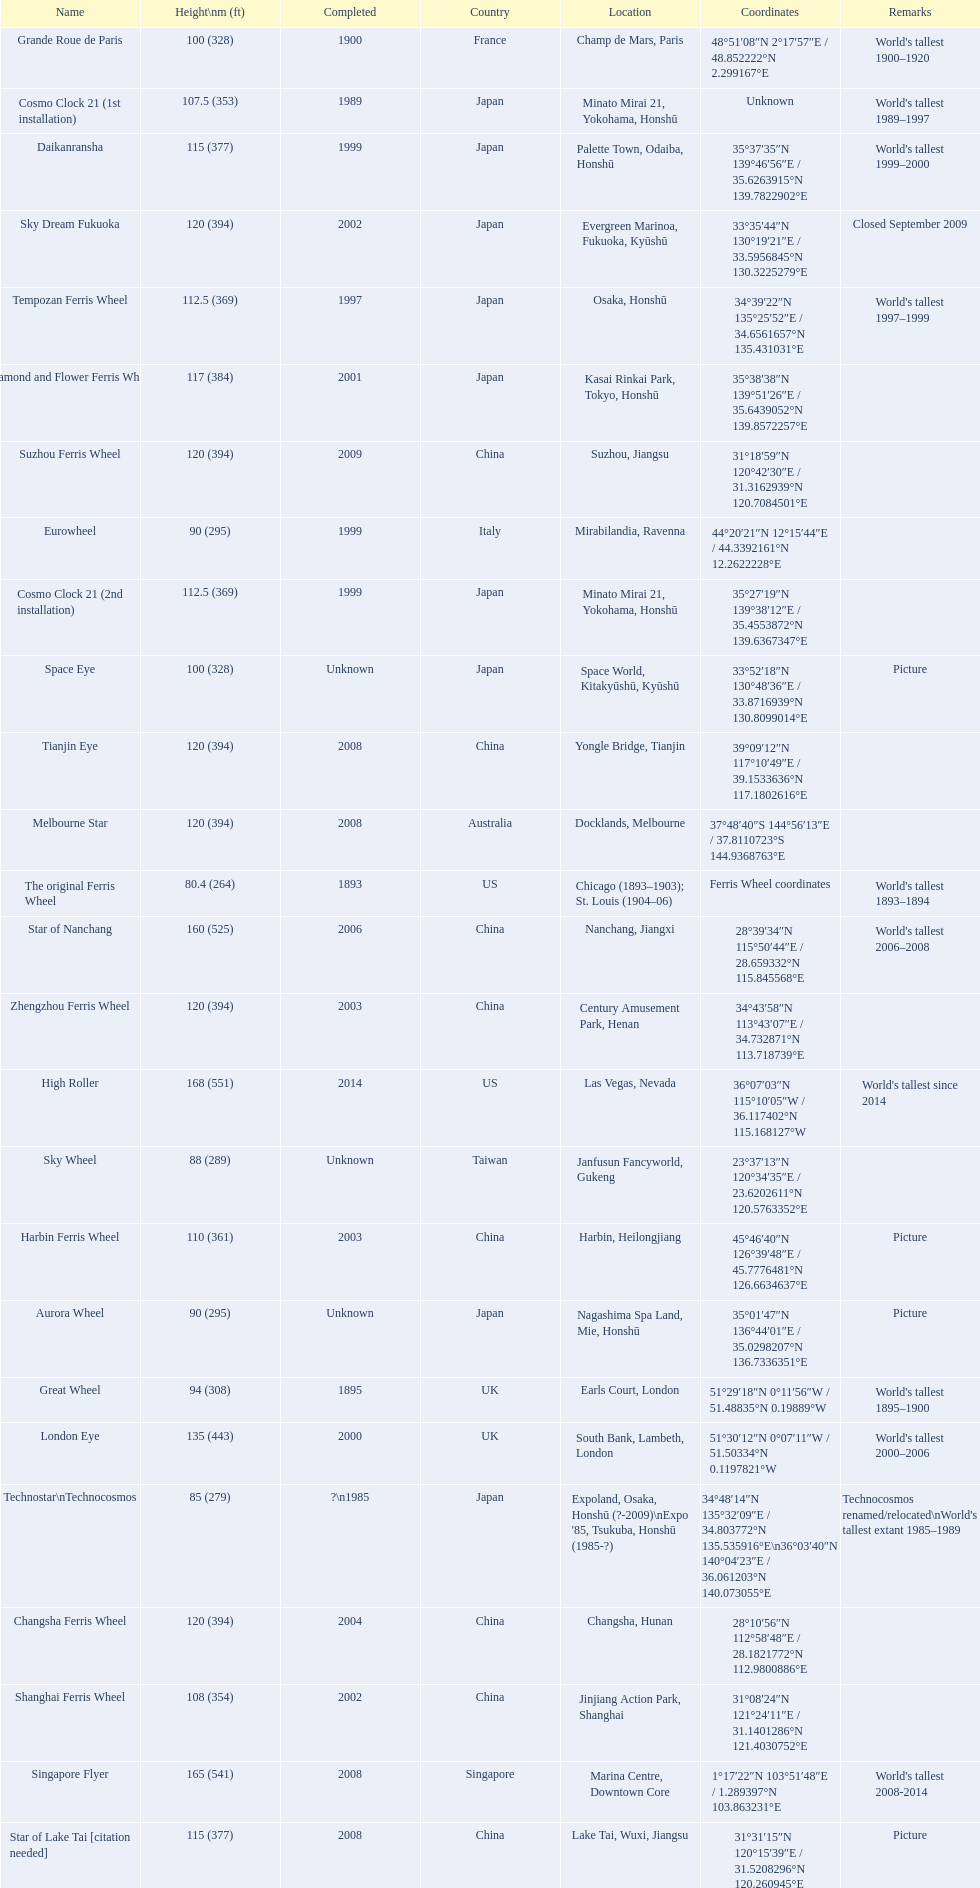What are all of the ferris wheel names? High Roller, Singapore Flyer, Star of Nanchang, London Eye, Suzhou Ferris Wheel, Melbourne Star, Tianjin Eye, Changsha Ferris Wheel, Zhengzhou Ferris Wheel, Sky Dream Fukuoka, Diamond and Flower Ferris Wheel, Star of Lake Tai [citation needed], Daikanransha, Cosmo Clock 21 (2nd installation), Tempozan Ferris Wheel, Harbin Ferris Wheel, Shanghai Ferris Wheel, Cosmo Clock 21 (1st installation), Space Eye, Grande Roue de Paris, Great Wheel, Aurora Wheel, Eurowheel, Sky Wheel, Technostar\nTechnocosmos, The original Ferris Wheel. What was the height of each one? 168 (551), 165 (541), 160 (525), 135 (443), 120 (394), 120 (394), 120 (394), 120 (394), 120 (394), 120 (394), 117 (384), 115 (377), 115 (377), 112.5 (369), 112.5 (369), 110 (361), 108 (354), 107.5 (353), 100 (328), 100 (328), 94 (308), 90 (295), 90 (295), 88 (289), 85 (279), 80.4 (264). Could you help me parse every detail presented in this table? {'header': ['Name', 'Height\\nm (ft)', 'Completed', 'Country', 'Location', 'Coordinates', 'Remarks'], 'rows': [['Grande Roue de Paris', '100 (328)', '1900', 'France', 'Champ de Mars, Paris', '48°51′08″N 2°17′57″E\ufeff / \ufeff48.852222°N 2.299167°E', "World's tallest 1900–1920"], ['Cosmo Clock 21 (1st installation)', '107.5 (353)', '1989', 'Japan', 'Minato Mirai 21, Yokohama, Honshū', 'Unknown', "World's tallest 1989–1997"], ['Daikanransha', '115 (377)', '1999', 'Japan', 'Palette Town, Odaiba, Honshū', '35°37′35″N 139°46′56″E\ufeff / \ufeff35.6263915°N 139.7822902°E', "World's tallest 1999–2000"], ['Sky Dream Fukuoka', '120 (394)', '2002', 'Japan', 'Evergreen Marinoa, Fukuoka, Kyūshū', '33°35′44″N 130°19′21″E\ufeff / \ufeff33.5956845°N 130.3225279°E', 'Closed September 2009'], ['Tempozan Ferris Wheel', '112.5 (369)', '1997', 'Japan', 'Osaka, Honshū', '34°39′22″N 135°25′52″E\ufeff / \ufeff34.6561657°N 135.431031°E', "World's tallest 1997–1999"], ['Diamond\xa0and\xa0Flower\xa0Ferris\xa0Wheel', '117 (384)', '2001', 'Japan', 'Kasai Rinkai Park, Tokyo, Honshū', '35°38′38″N 139°51′26″E\ufeff / \ufeff35.6439052°N 139.8572257°E', ''], ['Suzhou Ferris Wheel', '120 (394)', '2009', 'China', 'Suzhou, Jiangsu', '31°18′59″N 120°42′30″E\ufeff / \ufeff31.3162939°N 120.7084501°E', ''], ['Eurowheel', '90 (295)', '1999', 'Italy', 'Mirabilandia, Ravenna', '44°20′21″N 12°15′44″E\ufeff / \ufeff44.3392161°N 12.2622228°E', ''], ['Cosmo Clock 21 (2nd installation)', '112.5 (369)', '1999', 'Japan', 'Minato Mirai 21, Yokohama, Honshū', '35°27′19″N 139°38′12″E\ufeff / \ufeff35.4553872°N 139.6367347°E', ''], ['Space Eye', '100 (328)', 'Unknown', 'Japan', 'Space World, Kitakyūshū, Kyūshū', '33°52′18″N 130°48′36″E\ufeff / \ufeff33.8716939°N 130.8099014°E', 'Picture'], ['Tianjin Eye', '120 (394)', '2008', 'China', 'Yongle Bridge, Tianjin', '39°09′12″N 117°10′49″E\ufeff / \ufeff39.1533636°N 117.1802616°E', ''], ['Melbourne Star', '120 (394)', '2008', 'Australia', 'Docklands, Melbourne', '37°48′40″S 144°56′13″E\ufeff / \ufeff37.8110723°S 144.9368763°E', ''], ['The original Ferris Wheel', '80.4 (264)', '1893', 'US', 'Chicago (1893–1903); St. Louis (1904–06)', 'Ferris Wheel coordinates', "World's tallest 1893–1894"], ['Star of Nanchang', '160 (525)', '2006', 'China', 'Nanchang, Jiangxi', '28°39′34″N 115°50′44″E\ufeff / \ufeff28.659332°N 115.845568°E', "World's tallest 2006–2008"], ['Zhengzhou Ferris Wheel', '120 (394)', '2003', 'China', 'Century Amusement Park, Henan', '34°43′58″N 113°43′07″E\ufeff / \ufeff34.732871°N 113.718739°E', ''], ['High Roller', '168 (551)', '2014', 'US', 'Las Vegas, Nevada', '36°07′03″N 115°10′05″W\ufeff / \ufeff36.117402°N 115.168127°W', "World's tallest since 2014"], ['Sky Wheel', '88 (289)', 'Unknown', 'Taiwan', 'Janfusun Fancyworld, Gukeng', '23°37′13″N 120°34′35″E\ufeff / \ufeff23.6202611°N 120.5763352°E', ''], ['Harbin Ferris Wheel', '110 (361)', '2003', 'China', 'Harbin, Heilongjiang', '45°46′40″N 126°39′48″E\ufeff / \ufeff45.7776481°N 126.6634637°E', 'Picture'], ['Aurora Wheel', '90 (295)', 'Unknown', 'Japan', 'Nagashima Spa Land, Mie, Honshū', '35°01′47″N 136°44′01″E\ufeff / \ufeff35.0298207°N 136.7336351°E', 'Picture'], ['Great Wheel', '94 (308)', '1895', 'UK', 'Earls Court, London', '51°29′18″N 0°11′56″W\ufeff / \ufeff51.48835°N 0.19889°W', "World's tallest 1895–1900"], ['London Eye', '135 (443)', '2000', 'UK', 'South Bank, Lambeth, London', '51°30′12″N 0°07′11″W\ufeff / \ufeff51.50334°N 0.1197821°W', "World's tallest 2000–2006"], ['Technostar\\nTechnocosmos', '85 (279)', '?\\n1985', 'Japan', "Expoland, Osaka, Honshū (?-2009)\\nExpo '85, Tsukuba, Honshū (1985-?)", '34°48′14″N 135°32′09″E\ufeff / \ufeff34.803772°N 135.535916°E\\n36°03′40″N 140°04′23″E\ufeff / \ufeff36.061203°N 140.073055°E', "Technocosmos renamed/relocated\\nWorld's tallest extant 1985–1989"], ['Changsha Ferris Wheel', '120 (394)', '2004', 'China', 'Changsha, Hunan', '28°10′56″N 112°58′48″E\ufeff / \ufeff28.1821772°N 112.9800886°E', ''], ['Shanghai Ferris Wheel', '108 (354)', '2002', 'China', 'Jinjiang Action Park, Shanghai', '31°08′24″N 121°24′11″E\ufeff / \ufeff31.1401286°N 121.4030752°E', ''], ['Singapore Flyer', '165 (541)', '2008', 'Singapore', 'Marina Centre, Downtown Core', '1°17′22″N 103°51′48″E\ufeff / \ufeff1.289397°N 103.863231°E', "World's tallest 2008-2014"], ['Star of Lake Tai\xa0[citation needed]', '115 (377)', '2008', 'China', 'Lake Tai, Wuxi, Jiangsu', '31°31′15″N 120°15′39″E\ufeff / \ufeff31.5208296°N 120.260945°E', 'Picture']]} And when were they completed? 2014, 2008, 2006, 2000, 2009, 2008, 2008, 2004, 2003, 2002, 2001, 2008, 1999, 1999, 1997, 2003, 2002, 1989, Unknown, 1900, 1895, Unknown, 1999, Unknown, ?\n1985, 1893. Which were completed in 2008? Singapore Flyer, Melbourne Star, Tianjin Eye, Star of Lake Tai [citation needed]. And of those ferris wheels, which had a height of 165 meters? Singapore Flyer. 